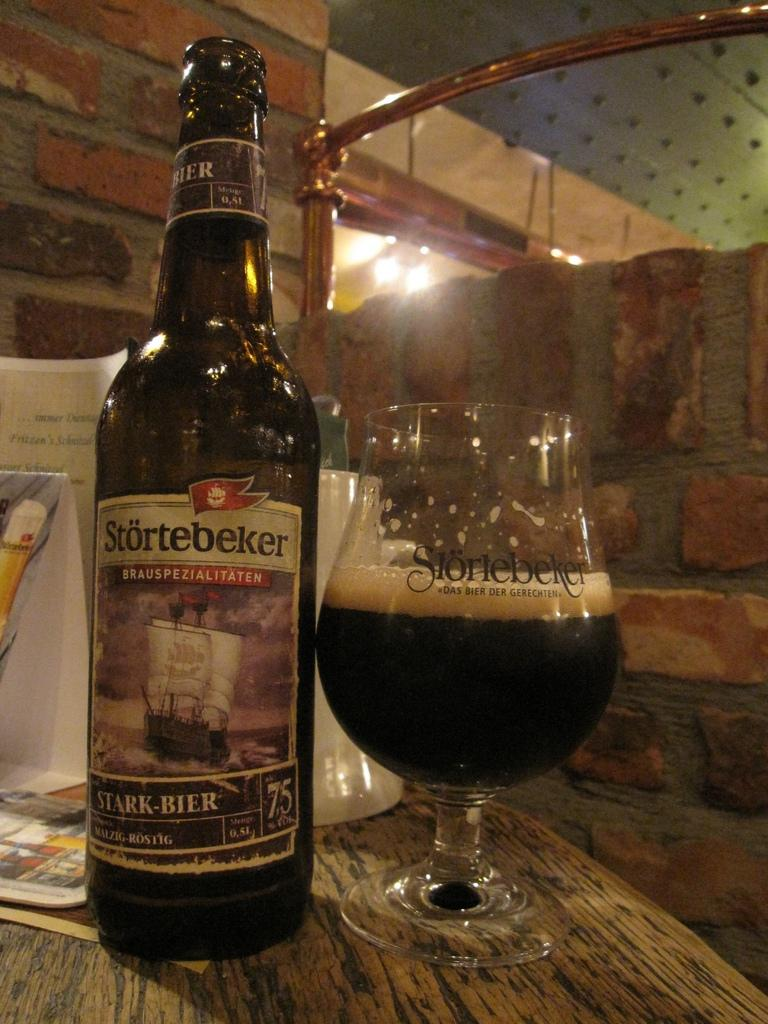<image>
Share a concise interpretation of the image provided. A bottle of dark beer named Stortebeker stands alongside a half glass of beer on a wooden table. 